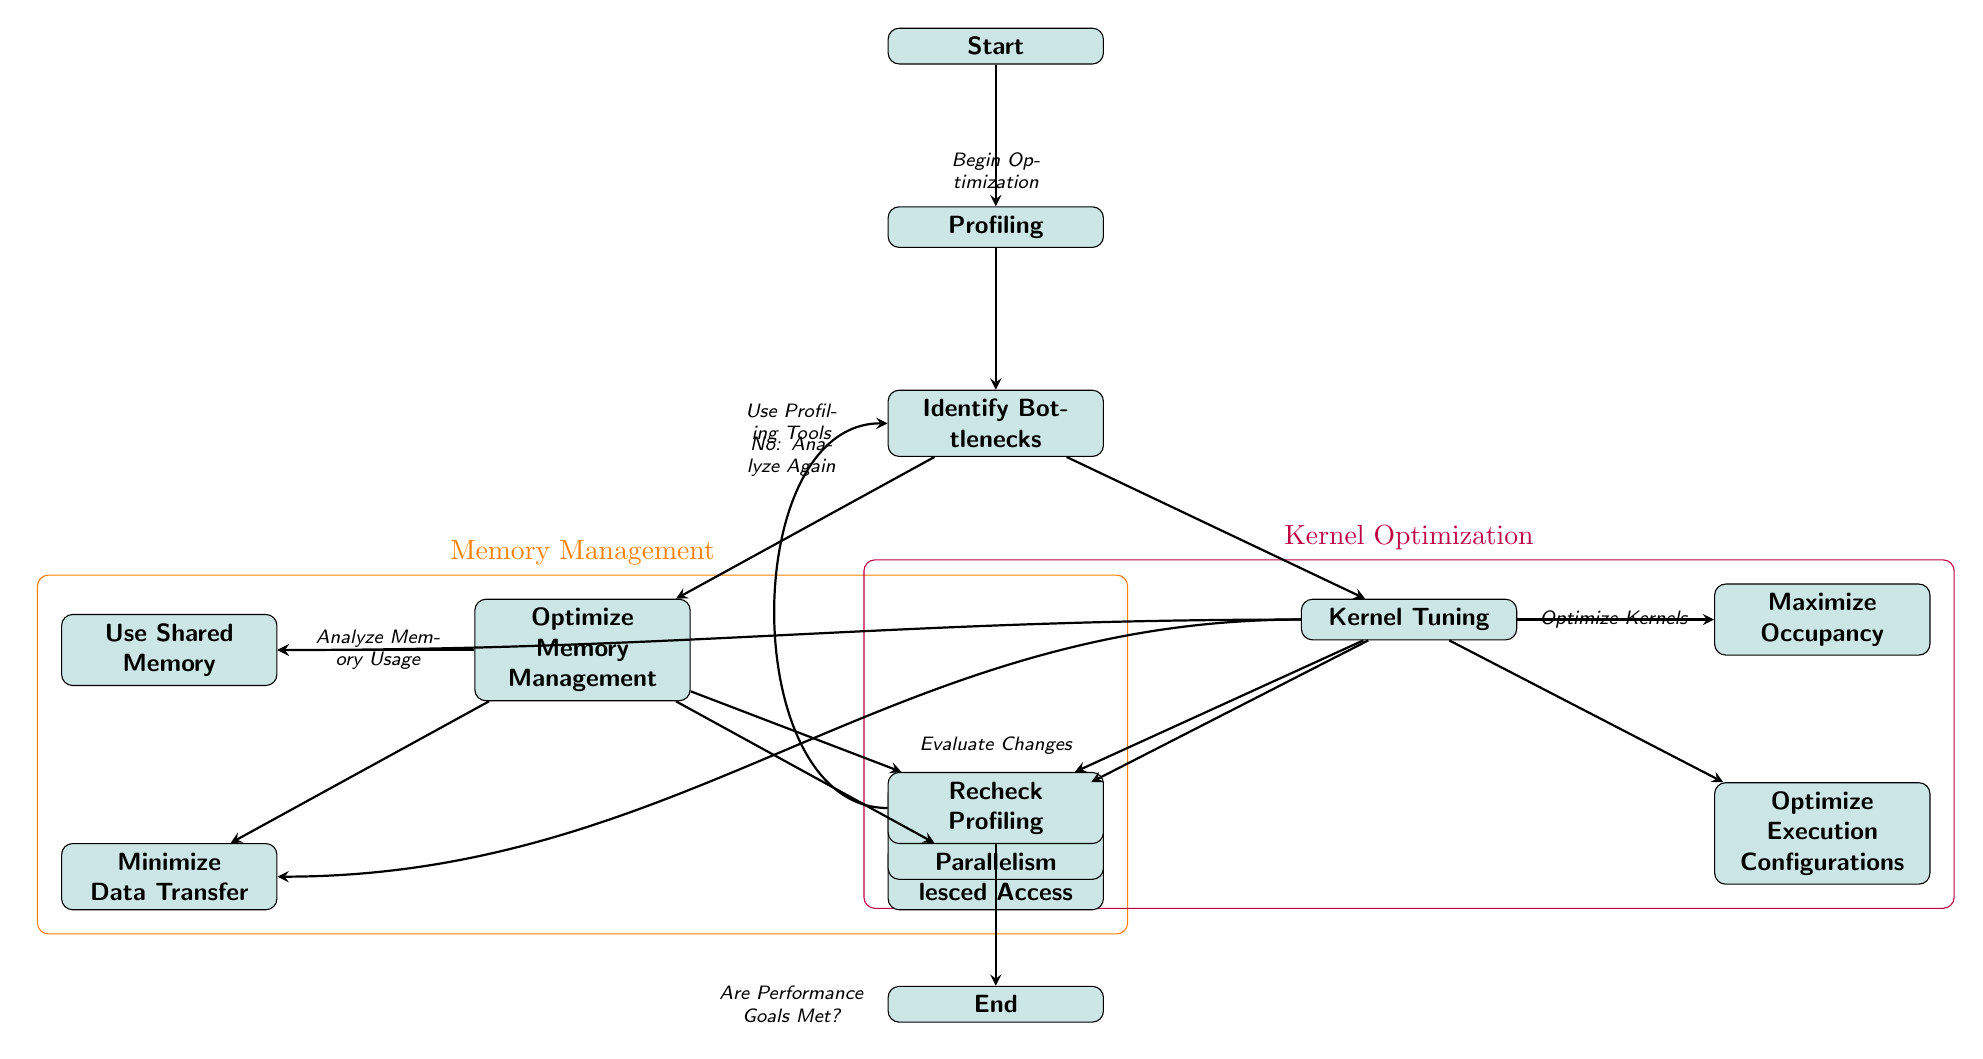What is the first step in the optimization process? The diagram indicates that the first step is labeled as "Start," leading directly to the "Profiling" step, which represents the beginning of the optimization process.
Answer: Profiling How many optimization strategies are identified in the diagram? The diagram features two main branches for optimization strategies: Memory Management and Kernel Optimization, each containing sub-strategies. Counting all individual nodes, there are five strategies listed.
Answer: Five What is the label above the "Memory Management" group? The label above this group is specifically marked in the diagram as "Memory Management," indicating the focus area of the strategies within this block.
Answer: Memory Management What should be done if performance goals are not met? The diagram states to "Analyze Again" if the performance goals are not met. This step connects back to the identification of bottlenecks for reevaluation.
Answer: Analyze Again Which strategy aims to maximize occupancy? Within the Kernel Tuning section of the diagram, the strategy intended to maximize occupancy is specifically labeled as "Maximize Occupancy." This label confirms its focus.
Answer: Maximize Occupancy What is the relationship between identifying bottlenecks and kernel tuning? In the diagram, identifying bottlenecks leads to two parallel paths: one for Memory Management and one for Kernel Tuning. This shows a direct connection, as both strategies emerge from the bottleneck identification step.
Answer: Both emerge from bottleneck identification What does the "Recheck Profiling" node lead to? Following the "Recheck Profiling" node, the diagram indicates a flow that leads into the "End" node, suggesting that this step concludes the optimization cycle.
Answer: End How many nodes are there in the Kernel Tuning section? The Kernel Tuning section contains four nodes: "Kernel Tuning," "Maximize Occupancy," "Increase Instruction-Level Parallelism," and "Optimize Execution Configurations." Thus, the total count is four.
Answer: Four What action should follow after the kernel optimization strategies are applied? Once the kernel optimization techniques are implemented, the next action is to "Recheck Profiling" to evaluate the effect of the changes made on performance.
Answer: Recheck Profiling 